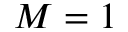<formula> <loc_0><loc_0><loc_500><loc_500>M = 1</formula> 